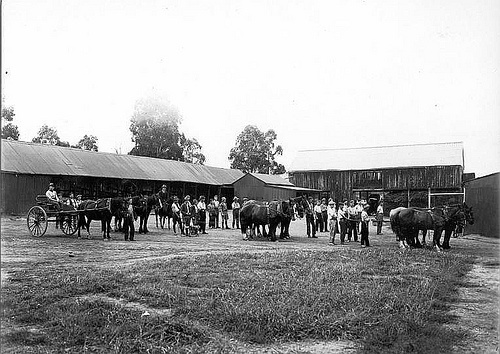Describe the objects in this image and their specific colors. I can see people in darkgray, black, gray, and lightgray tones, horse in darkgray, black, gray, and lightgray tones, horse in darkgray, black, gray, and lightgray tones, horse in darkgray, black, gray, and gainsboro tones, and people in darkgray, black, gray, and lightgray tones in this image. 